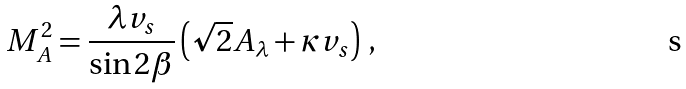Convert formula to latex. <formula><loc_0><loc_0><loc_500><loc_500>M _ { A } ^ { 2 } = \frac { \lambda v _ { s } } { \sin 2 \beta } \left ( \sqrt { 2 } A _ { \lambda } + \kappa v _ { s } \right ) \, ,</formula> 